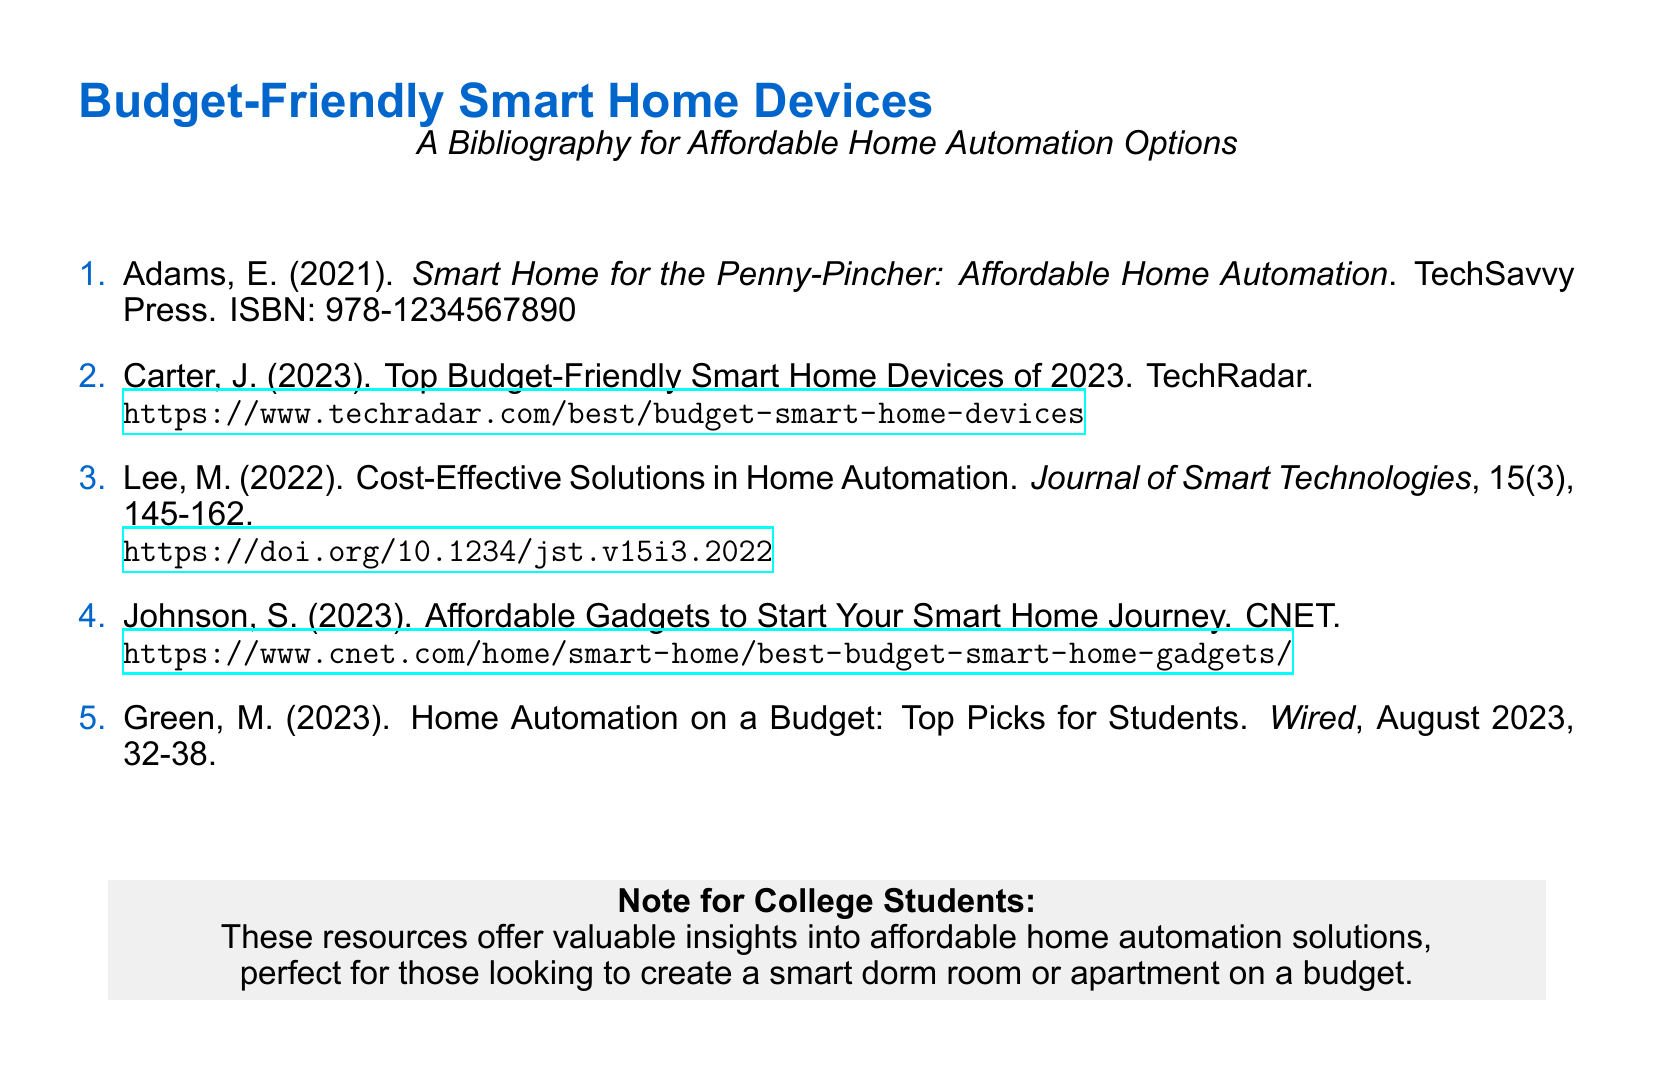What is the title of the first entry? The title of the first entry is indicated after the author's name and year of publication, which reads "Smart Home for the Penny-Pincher: Affordable Home Automation."
Answer: Smart Home for the Penny-Pincher: Affordable Home Automation Who published the 2023 article by Johnson? The publisher is noted next to the author's name in the bibliography, which is CNET.
Answer: CNET What is the volume number of Lee's article? The volume number is specified in the citation format of the journal entry, which reads volume 15.
Answer: 15 In what year was the bibliography document published? The publication years of the bibliography entries indicate a range that includes 2023, so the latest information reflects that year.
Answer: 2023 What is the focus of Green's article as mentioned in the title? The title indicates it is about home automation on a budget specifically targeting students.
Answer: Home Automation on a Budget What type of document is this? The structure and content, including the list format and included citations, indicate that it is a bibliography.
Answer: Bibliography What is the overall theme of the resources listed? The overarching theme pertains to low-cost options for creating smart home solutions, as inferred from the titles and publication contents.
Answer: Affordable home automation solutions 